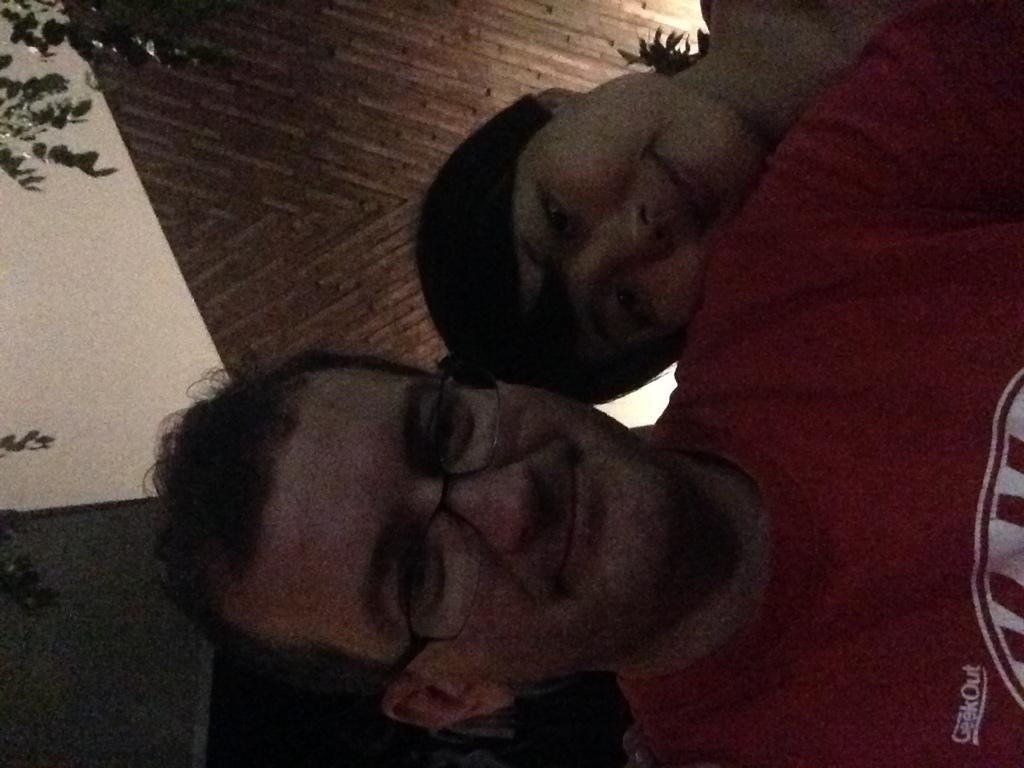What is the condition of the picture in the image? The picture is tilted in the image. Who or what is depicted in the picture? The picture contains two people. What is the facial expression of the people in the image? The people are smiling. What are the people looking at in the image? The people are looking at something, but it is not visible in the image. What type of vegetation can be seen in the background of the image? There are green leaves in the background of the image. What color is the wall visible in the background of the image? There is a brown wall in the background of the image. Where is the tent set up in the image? There is no tent present in the image. What type of sofa can be seen in the image? There is no sofa present in the image. 